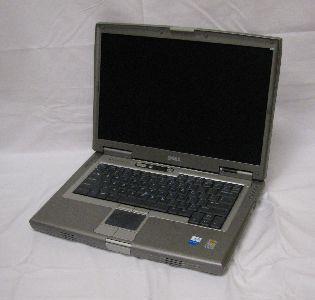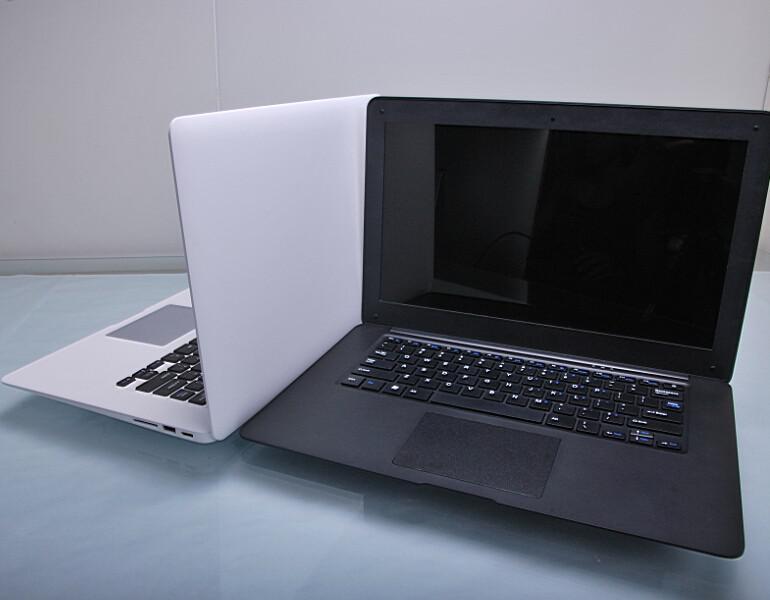The first image is the image on the left, the second image is the image on the right. Evaluate the accuracy of this statement regarding the images: "There are three computers". Is it true? Answer yes or no. Yes. The first image is the image on the left, the second image is the image on the right. Examine the images to the left and right. Is the description "There are two laptops in one of the images." accurate? Answer yes or no. Yes. 